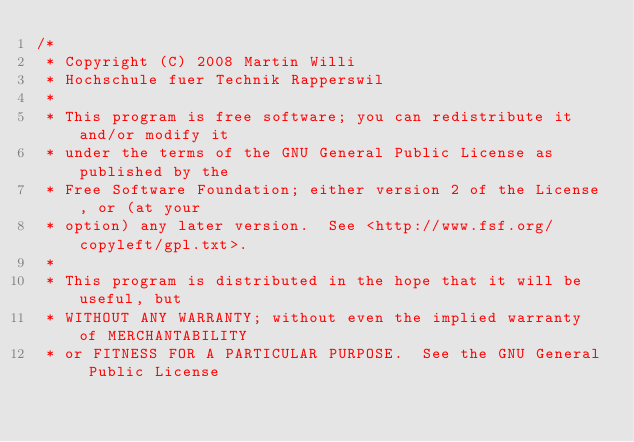Convert code to text. <code><loc_0><loc_0><loc_500><loc_500><_C_>/*
 * Copyright (C) 2008 Martin Willi
 * Hochschule fuer Technik Rapperswil
 *
 * This program is free software; you can redistribute it and/or modify it
 * under the terms of the GNU General Public License as published by the
 * Free Software Foundation; either version 2 of the License, or (at your
 * option) any later version.  See <http://www.fsf.org/copyleft/gpl.txt>.
 *
 * This program is distributed in the hope that it will be useful, but
 * WITHOUT ANY WARRANTY; without even the implied warranty of MERCHANTABILITY
 * or FITNESS FOR A PARTICULAR PURPOSE.  See the GNU General Public License</code> 